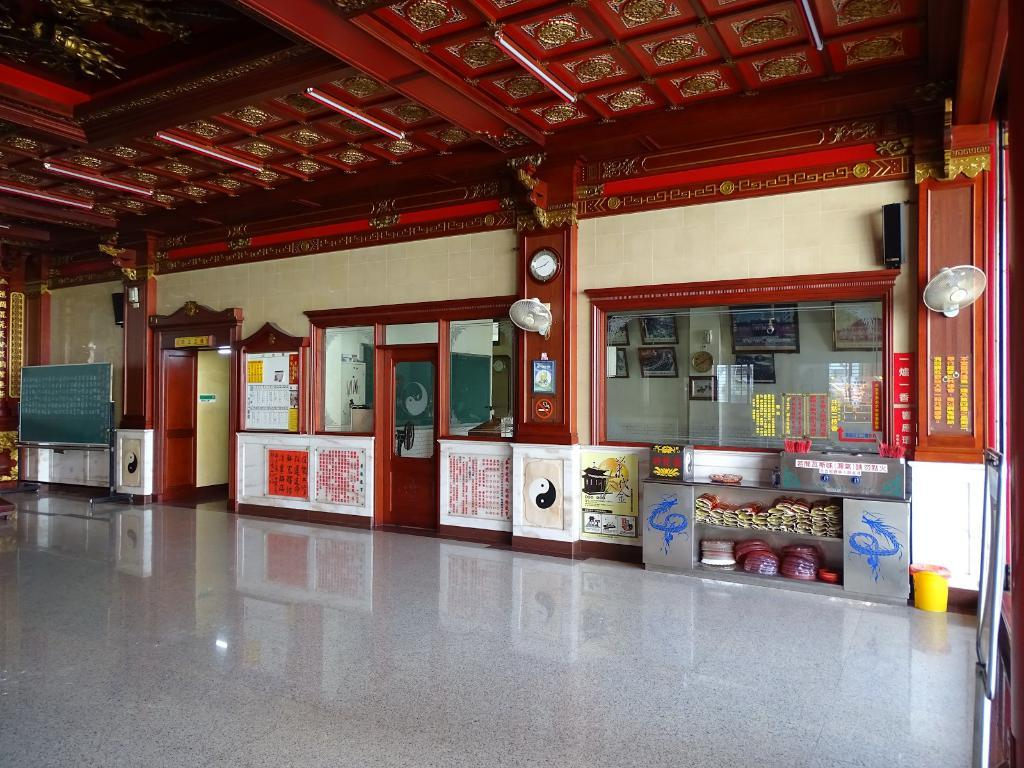<image>
Give a short and clear explanation of the subsequent image. the inside of a building with a no smoking sign on the wlal 